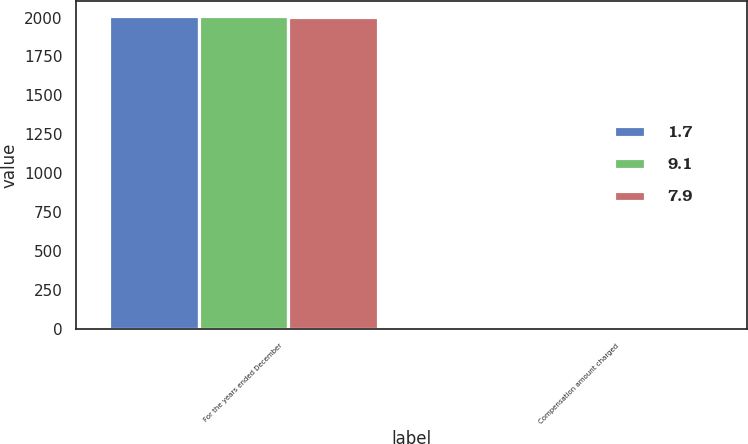<chart> <loc_0><loc_0><loc_500><loc_500><stacked_bar_chart><ecel><fcel>For the years ended December<fcel>Compensation amount charged<nl><fcel>1.7<fcel>2008<fcel>9.1<nl><fcel>9.1<fcel>2007<fcel>1.7<nl><fcel>7.9<fcel>2006<fcel>7.9<nl></chart> 